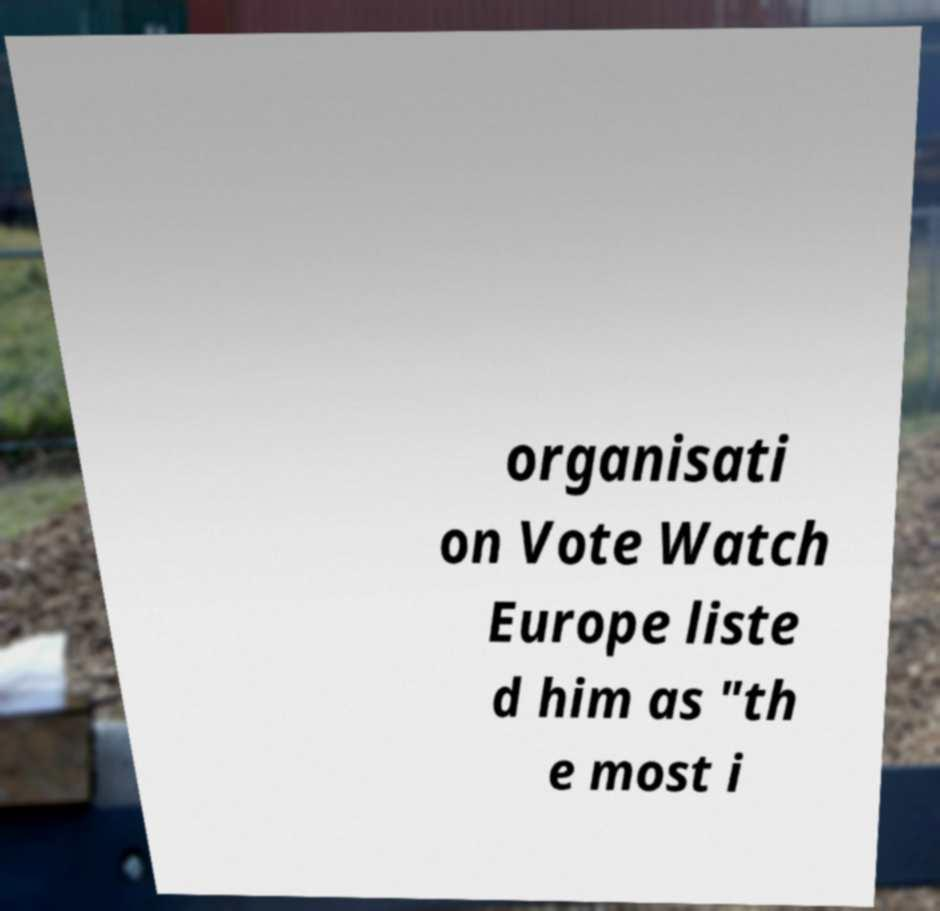There's text embedded in this image that I need extracted. Can you transcribe it verbatim? organisati on Vote Watch Europe liste d him as "th e most i 